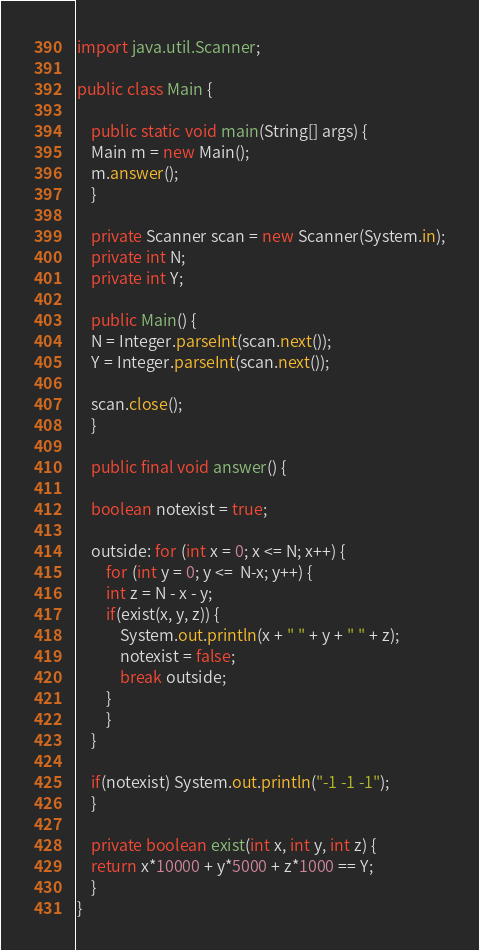<code> <loc_0><loc_0><loc_500><loc_500><_Java_>import java.util.Scanner;

public class Main {

    public static void main(String[] args) {
	Main m = new Main();
	m.answer();
    }

    private Scanner scan = new Scanner(System.in);
    private int N;
    private int Y;

    public Main() {
	N = Integer.parseInt(scan.next());
	Y = Integer.parseInt(scan.next());

	scan.close();
    }

    public final void answer() {

	boolean notexist = true;

	outside: for (int x = 0; x <= N; x++) {
	    for (int y = 0; y <=  N-x; y++) {
		int z = N - x - y;
		if(exist(x, y, z)) {
		    System.out.println(x + " " + y + " " + z);
		    notexist = false;
		    break outside;
		}
	    }
	}

	if(notexist) System.out.println("-1 -1 -1");
    }

    private boolean exist(int x, int y, int z) {
	return x*10000 + y*5000 + z*1000 == Y;
    }
}
</code> 